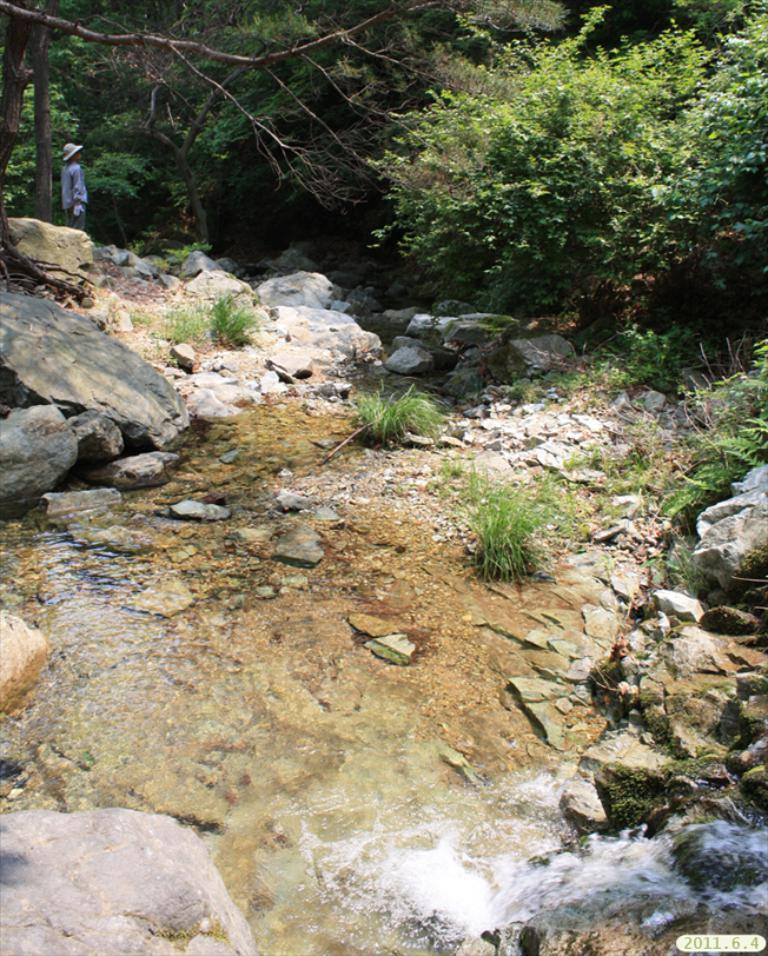What type of living organisms can be seen in the image? Plants can be seen in the image. What type of establishments are present in the image? There are stores in the image. What natural element is visible in the image? Water is visible in the image. What is the person in the image wearing? The person is wearing a hat in the image. What is the person in the image doing? The person is standing in the image. What can be seen in the background of the image? There are trees in the background of the image. How many doctors are present in the image? There are no doctors present in the image. What type of hole can be seen in the image? There is no hole present in the image. 